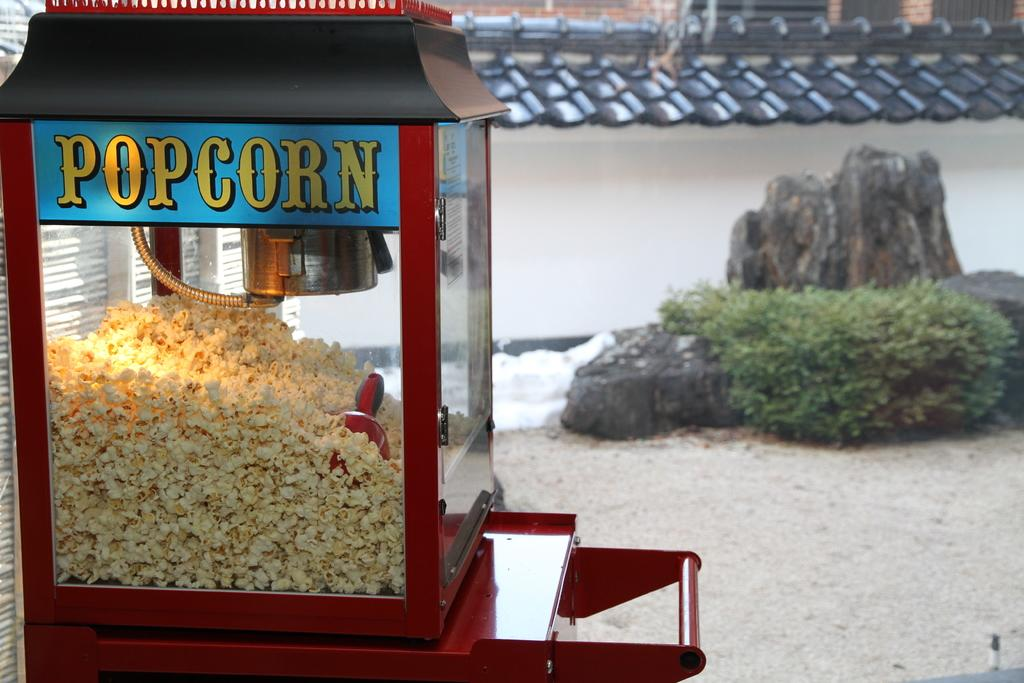<image>
Present a compact description of the photo's key features. A red popcorn machine is filled up with popcorn ready to be served. 